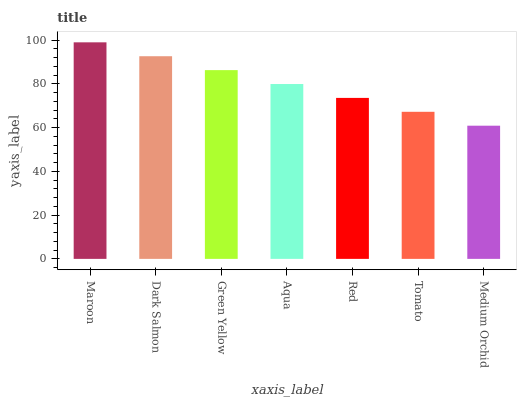Is Medium Orchid the minimum?
Answer yes or no. Yes. Is Maroon the maximum?
Answer yes or no. Yes. Is Dark Salmon the minimum?
Answer yes or no. No. Is Dark Salmon the maximum?
Answer yes or no. No. Is Maroon greater than Dark Salmon?
Answer yes or no. Yes. Is Dark Salmon less than Maroon?
Answer yes or no. Yes. Is Dark Salmon greater than Maroon?
Answer yes or no. No. Is Maroon less than Dark Salmon?
Answer yes or no. No. Is Aqua the high median?
Answer yes or no. Yes. Is Aqua the low median?
Answer yes or no. Yes. Is Medium Orchid the high median?
Answer yes or no. No. Is Maroon the low median?
Answer yes or no. No. 